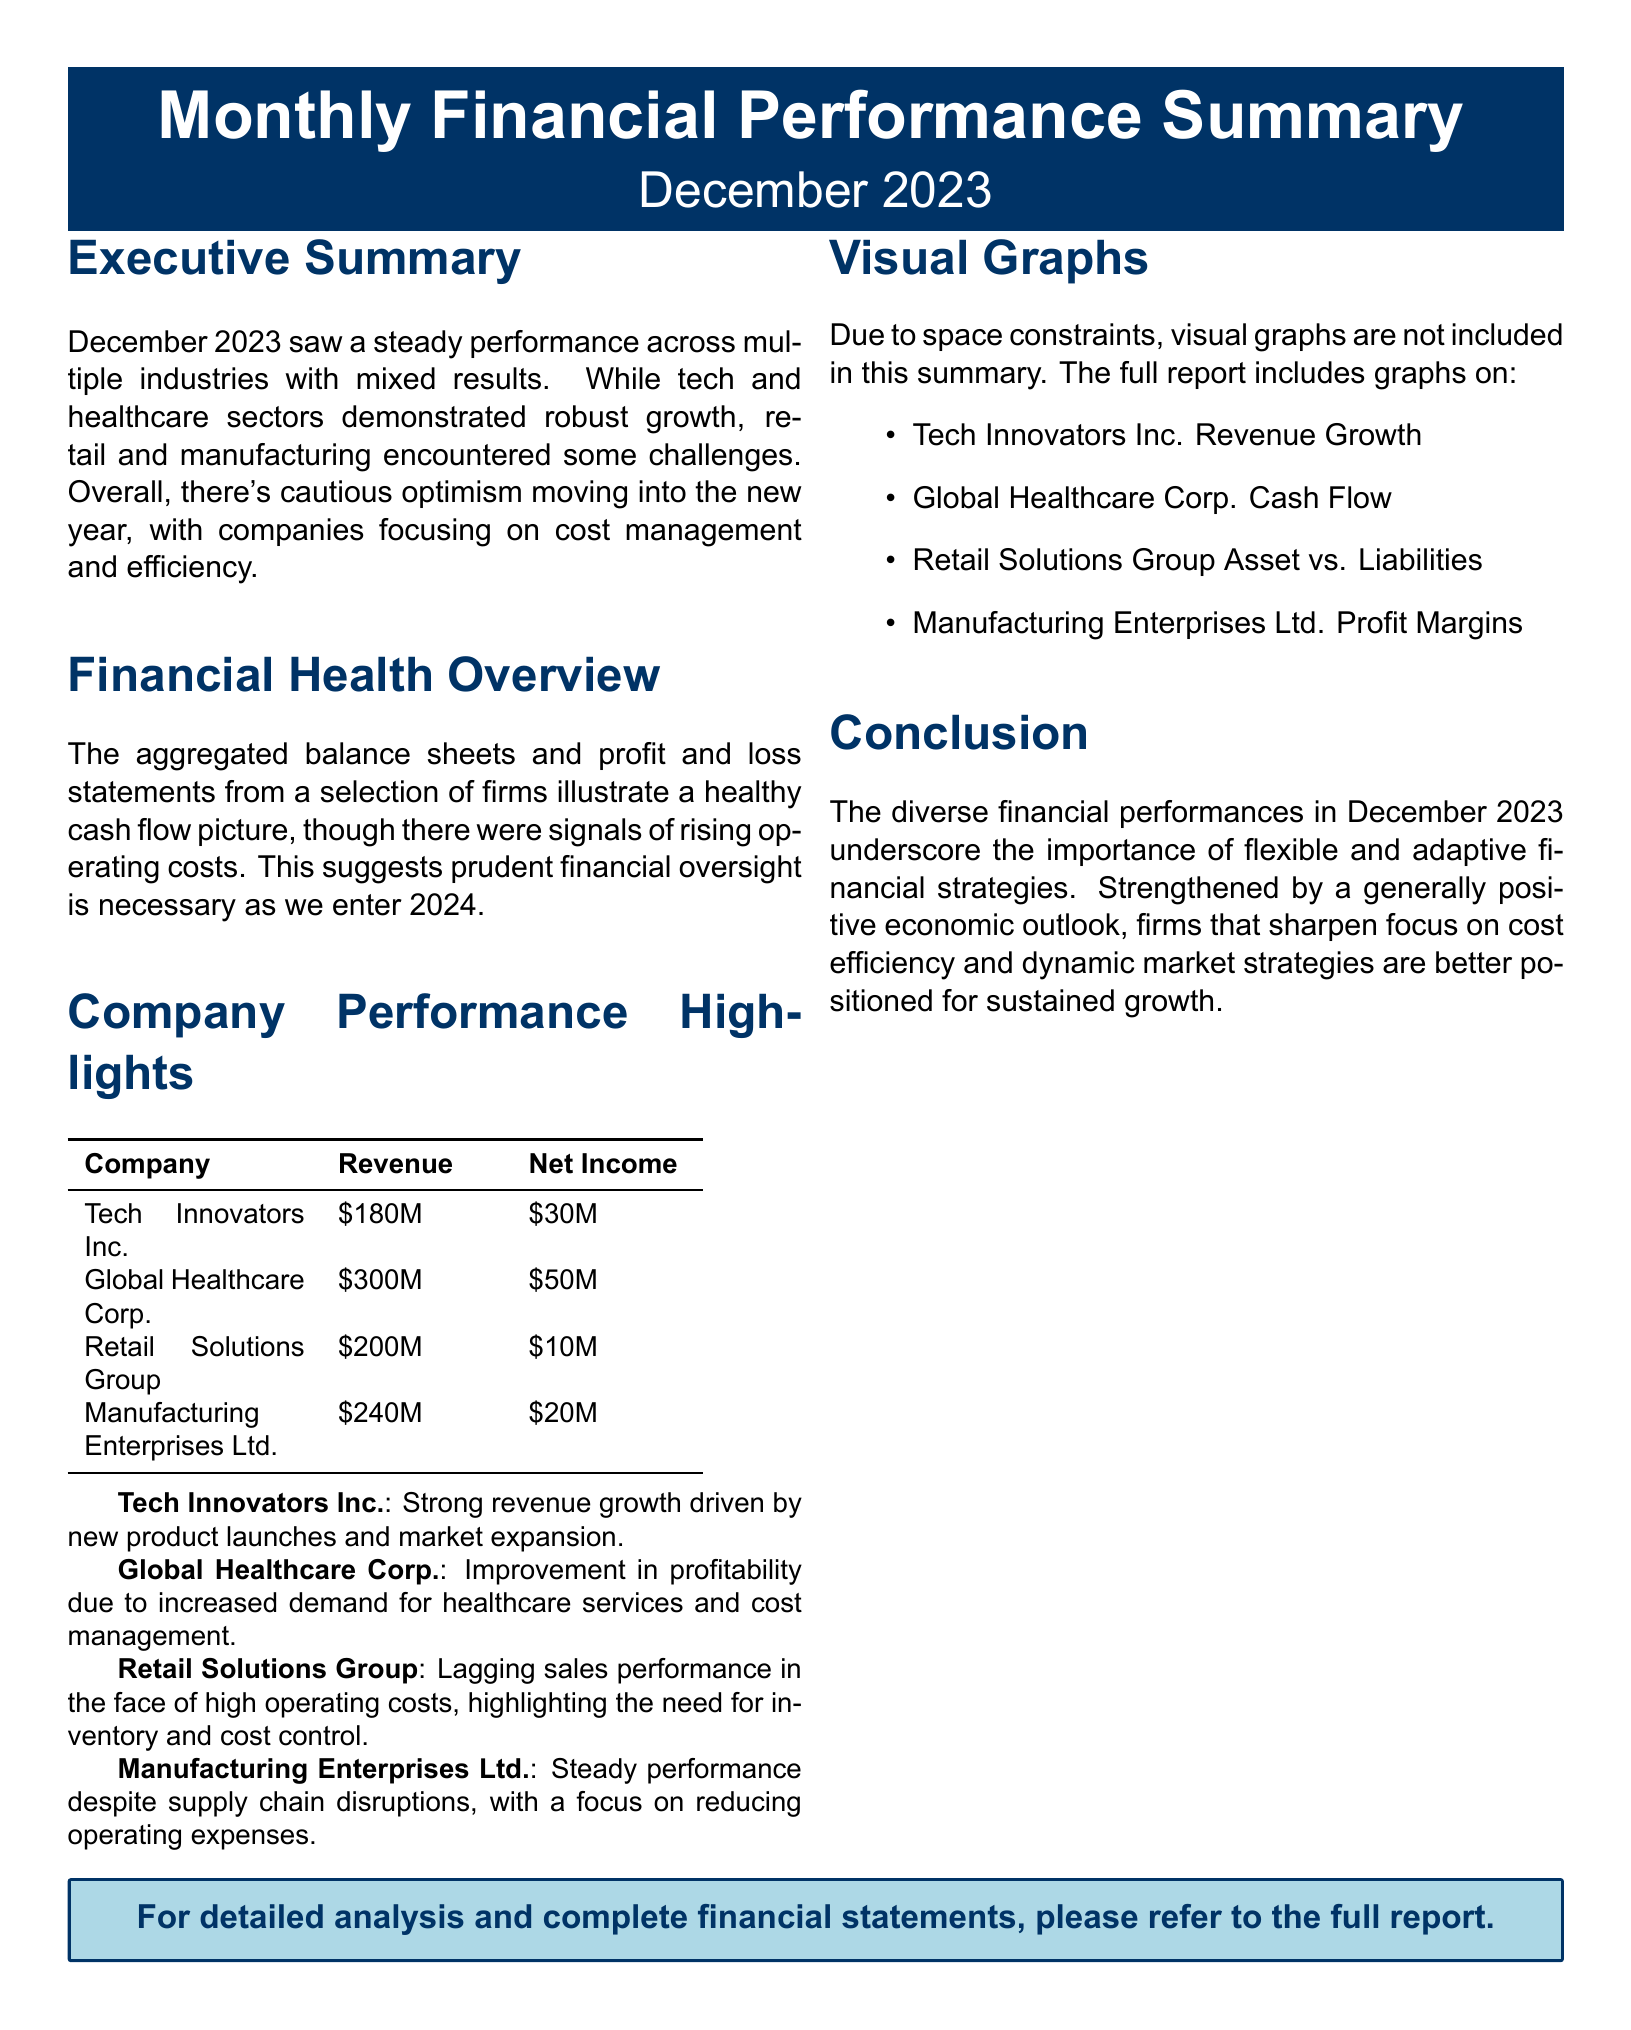What was the revenue for Global Healthcare Corp.? The document states that Global Healthcare Corp. had a revenue of $300M.
Answer: $300M What is the net income of Tech Innovators Inc.? According to the company performance highlights, Tech Innovators Inc. reported a net income of $30M.
Answer: $30M Which sector showed robust growth in December 2023? The executive summary mentions that the tech and healthcare sectors demonstrated robust growth.
Answer: Tech and Healthcare What challenges did the retail sector face? The document highlights high operating costs as a challenge for the retail sector.
Answer: High operating costs What overall sentiment does the executive summary convey about the economic outlook for 2024? The executive summary notes a cautious optimism as companies focus on cost management and efficiency.
Answer: Cautious optimism Which company had the highest net income? Reviewing the company performance highlights, Global Healthcare Corp. had the highest net income of $50M.
Answer: $50M What is the significance of the company's performance in December 2023? The conclusion emphasizes the importance of flexible and adaptive financial strategies for sustained growth.
Answer: Flexible and adaptive strategies What are the main focus areas for companies moving into 2024? The conclusion suggests that companies should sharpen focus on cost efficiency and dynamic market strategies.
Answer: Cost efficiency and dynamic market strategies What does the financial health overview suggest is necessary as we enter 2024? The financial health overview indicates that prudent financial oversight is necessary entering 2024.
Answer: Prudent financial oversight 